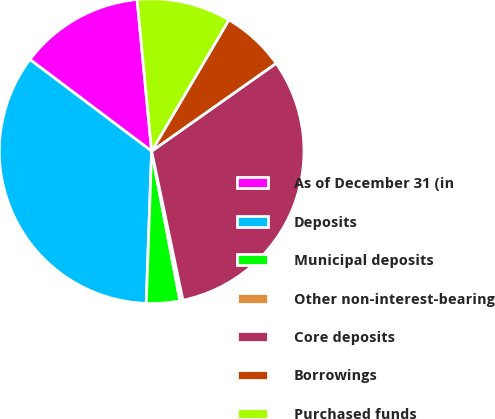<chart> <loc_0><loc_0><loc_500><loc_500><pie_chart><fcel>As of December 31 (in<fcel>Deposits<fcel>Municipal deposits<fcel>Other non-interest-bearing<fcel>Core deposits<fcel>Borrowings<fcel>Purchased funds<nl><fcel>13.21%<fcel>34.7%<fcel>3.54%<fcel>0.32%<fcel>31.48%<fcel>6.76%<fcel>9.98%<nl></chart> 